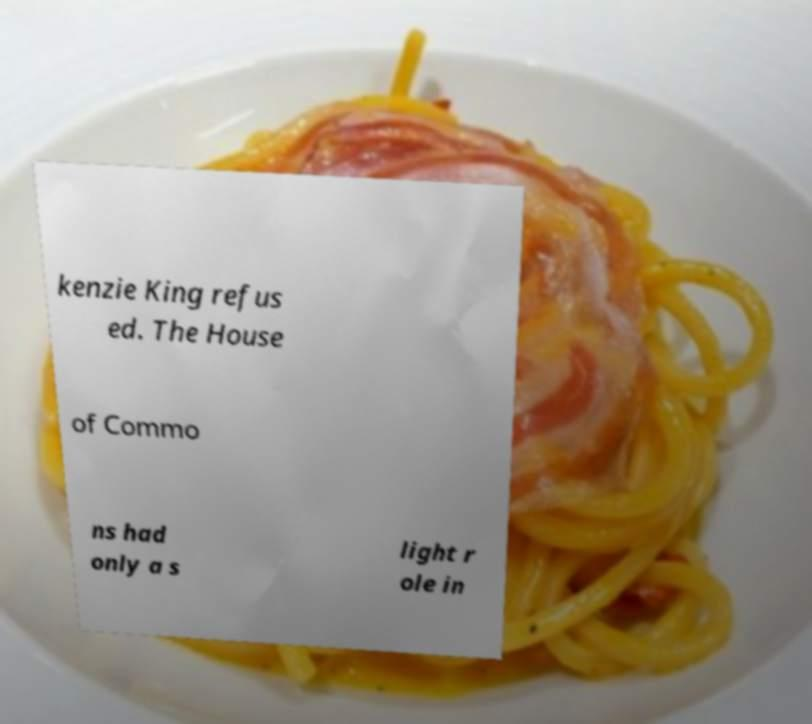I need the written content from this picture converted into text. Can you do that? kenzie King refus ed. The House of Commo ns had only a s light r ole in 